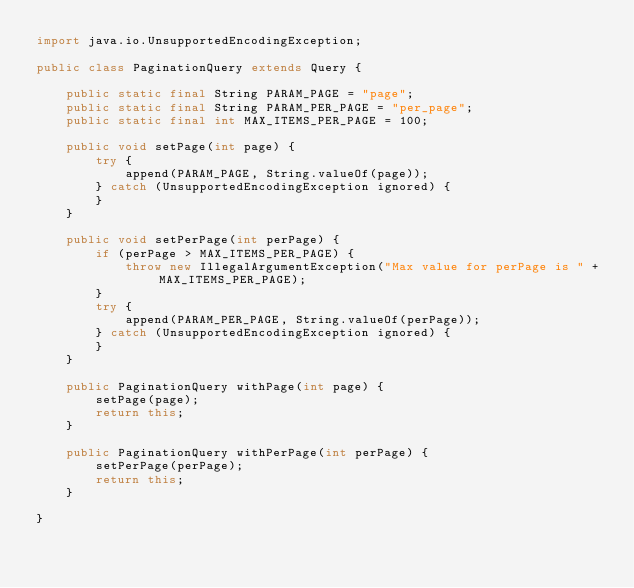<code> <loc_0><loc_0><loc_500><loc_500><_Java_>import java.io.UnsupportedEncodingException;

public class PaginationQuery extends Query {

    public static final String PARAM_PAGE = "page";
    public static final String PARAM_PER_PAGE = "per_page";
    public static final int MAX_ITEMS_PER_PAGE = 100;

    public void setPage(int page) {
        try {
            append(PARAM_PAGE, String.valueOf(page));
        } catch (UnsupportedEncodingException ignored) {
        }
    }

    public void setPerPage(int perPage) {
        if (perPage > MAX_ITEMS_PER_PAGE) {
            throw new IllegalArgumentException("Max value for perPage is " + MAX_ITEMS_PER_PAGE);
        }
        try {
            append(PARAM_PER_PAGE, String.valueOf(perPage));
        } catch (UnsupportedEncodingException ignored) {
        }
    }

    public PaginationQuery withPage(int page) {
        setPage(page);
        return this;
    }

    public PaginationQuery withPerPage(int perPage) {
        setPerPage(perPage);
        return this;
    }

}
</code> 